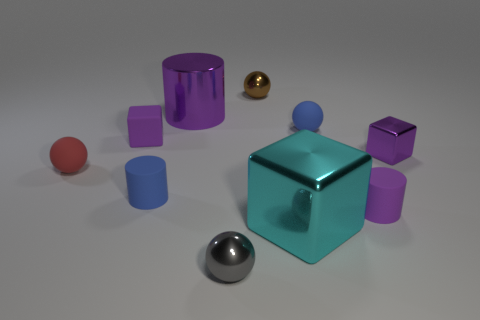How many objects are either small objects behind the small gray sphere or small cyan spheres?
Make the answer very short. 7. What number of gray spheres have the same material as the cyan object?
Offer a terse response. 1. The shiny thing that is the same color as the tiny shiny block is what shape?
Provide a succinct answer. Cylinder. Is the number of cyan metallic blocks right of the cyan shiny thing the same as the number of tiny blue matte cylinders?
Your response must be concise. No. There is a purple matte object on the right side of the cyan cube; what size is it?
Offer a very short reply. Small. What number of small objects are either cyan objects or rubber spheres?
Your response must be concise. 2. What color is the other matte object that is the same shape as the large cyan object?
Your answer should be very brief. Purple. Does the red matte object have the same size as the purple metal cylinder?
Provide a short and direct response. No. How many objects are either tiny red matte blocks or tiny shiny objects behind the big purple cylinder?
Your answer should be very brief. 1. There is a big thing behind the tiny rubber sphere that is right of the big block; what is its color?
Make the answer very short. Purple. 